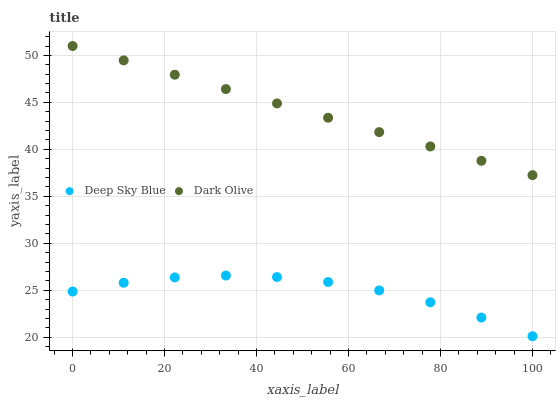Does Deep Sky Blue have the minimum area under the curve?
Answer yes or no. Yes. Does Dark Olive have the maximum area under the curve?
Answer yes or no. Yes. Does Deep Sky Blue have the maximum area under the curve?
Answer yes or no. No. Is Dark Olive the smoothest?
Answer yes or no. Yes. Is Deep Sky Blue the roughest?
Answer yes or no. Yes. Is Deep Sky Blue the smoothest?
Answer yes or no. No. Does Deep Sky Blue have the lowest value?
Answer yes or no. Yes. Does Dark Olive have the highest value?
Answer yes or no. Yes. Does Deep Sky Blue have the highest value?
Answer yes or no. No. Is Deep Sky Blue less than Dark Olive?
Answer yes or no. Yes. Is Dark Olive greater than Deep Sky Blue?
Answer yes or no. Yes. Does Deep Sky Blue intersect Dark Olive?
Answer yes or no. No. 